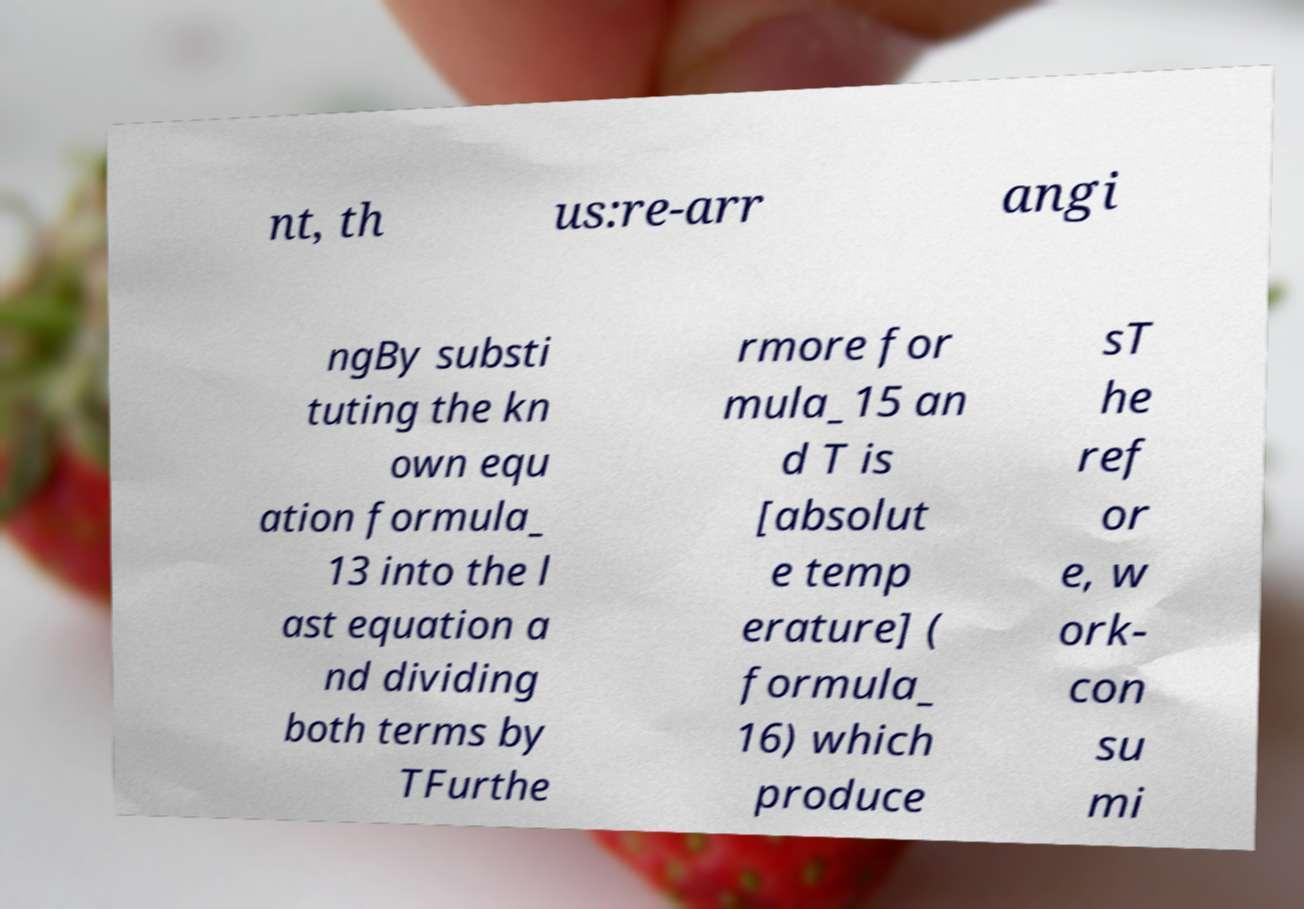Please identify and transcribe the text found in this image. nt, th us:re-arr angi ngBy substi tuting the kn own equ ation formula_ 13 into the l ast equation a nd dividing both terms by TFurthe rmore for mula_15 an d T is [absolut e temp erature] ( formula_ 16) which produce sT he ref or e, w ork- con su mi 